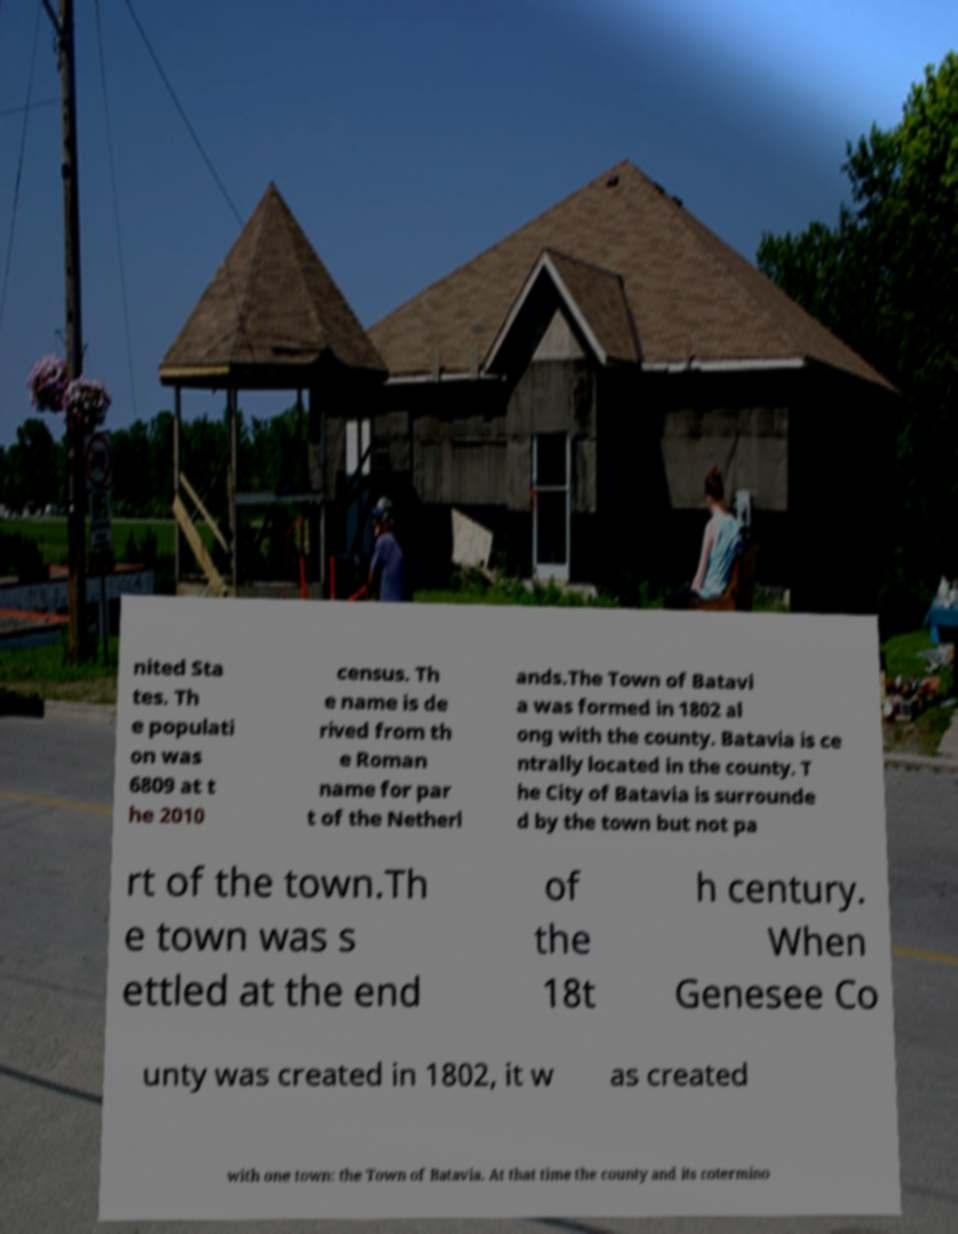What messages or text are displayed in this image? I need them in a readable, typed format. nited Sta tes. Th e populati on was 6809 at t he 2010 census. Th e name is de rived from th e Roman name for par t of the Netherl ands.The Town of Batavi a was formed in 1802 al ong with the county. Batavia is ce ntrally located in the county. T he City of Batavia is surrounde d by the town but not pa rt of the town.Th e town was s ettled at the end of the 18t h century. When Genesee Co unty was created in 1802, it w as created with one town: the Town of Batavia. At that time the county and its cotermino 